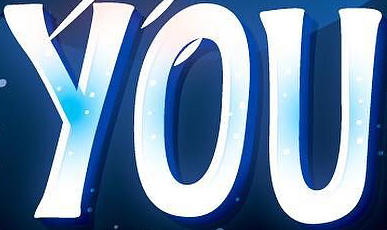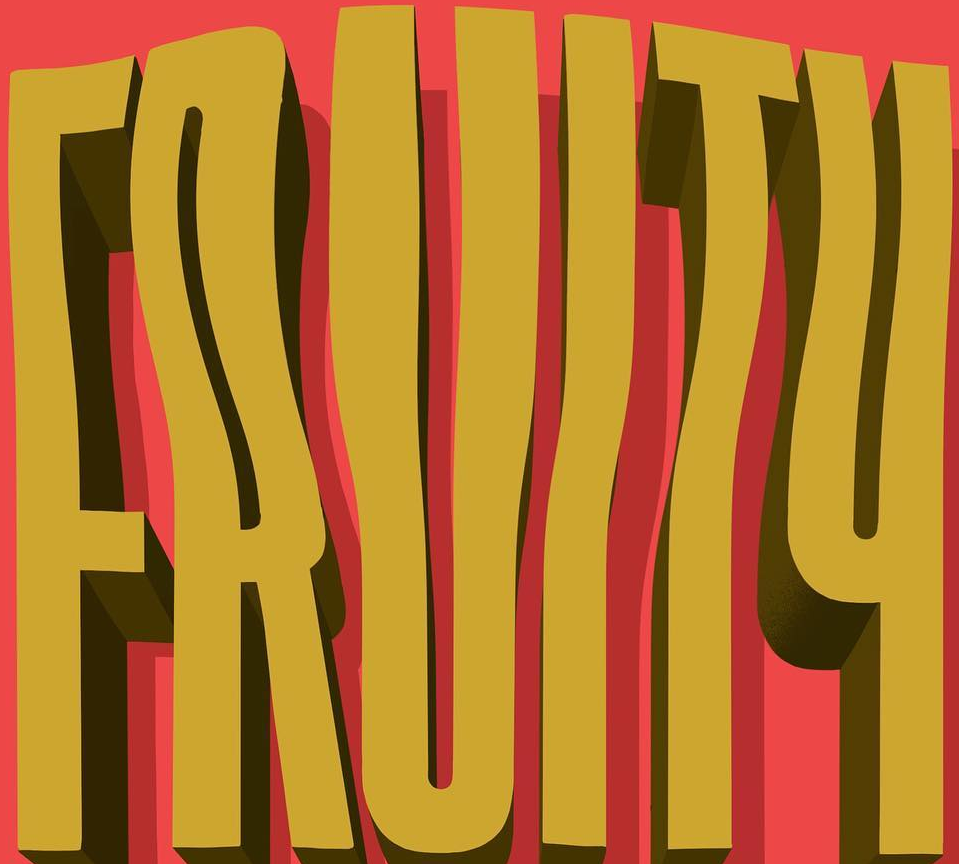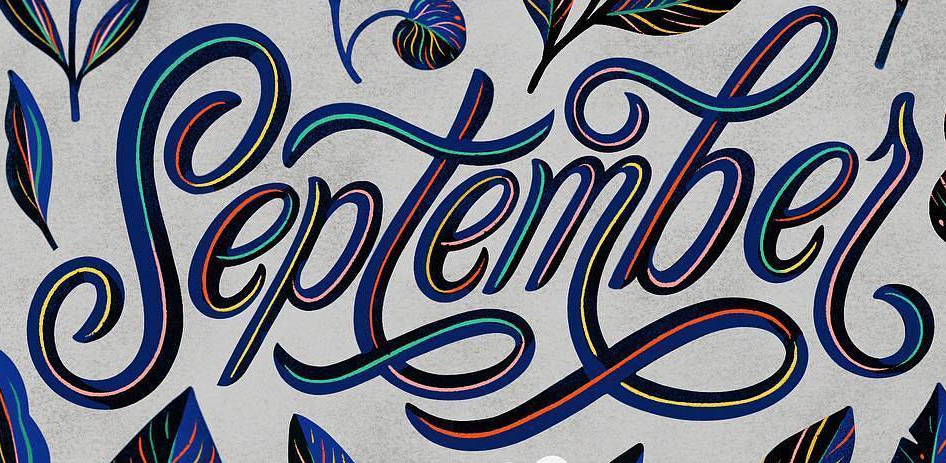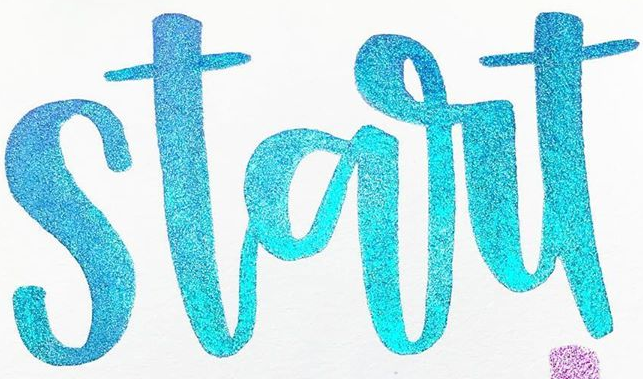What words can you see in these images in sequence, separated by a semicolon? YOU; FRUITY; septembel; start 